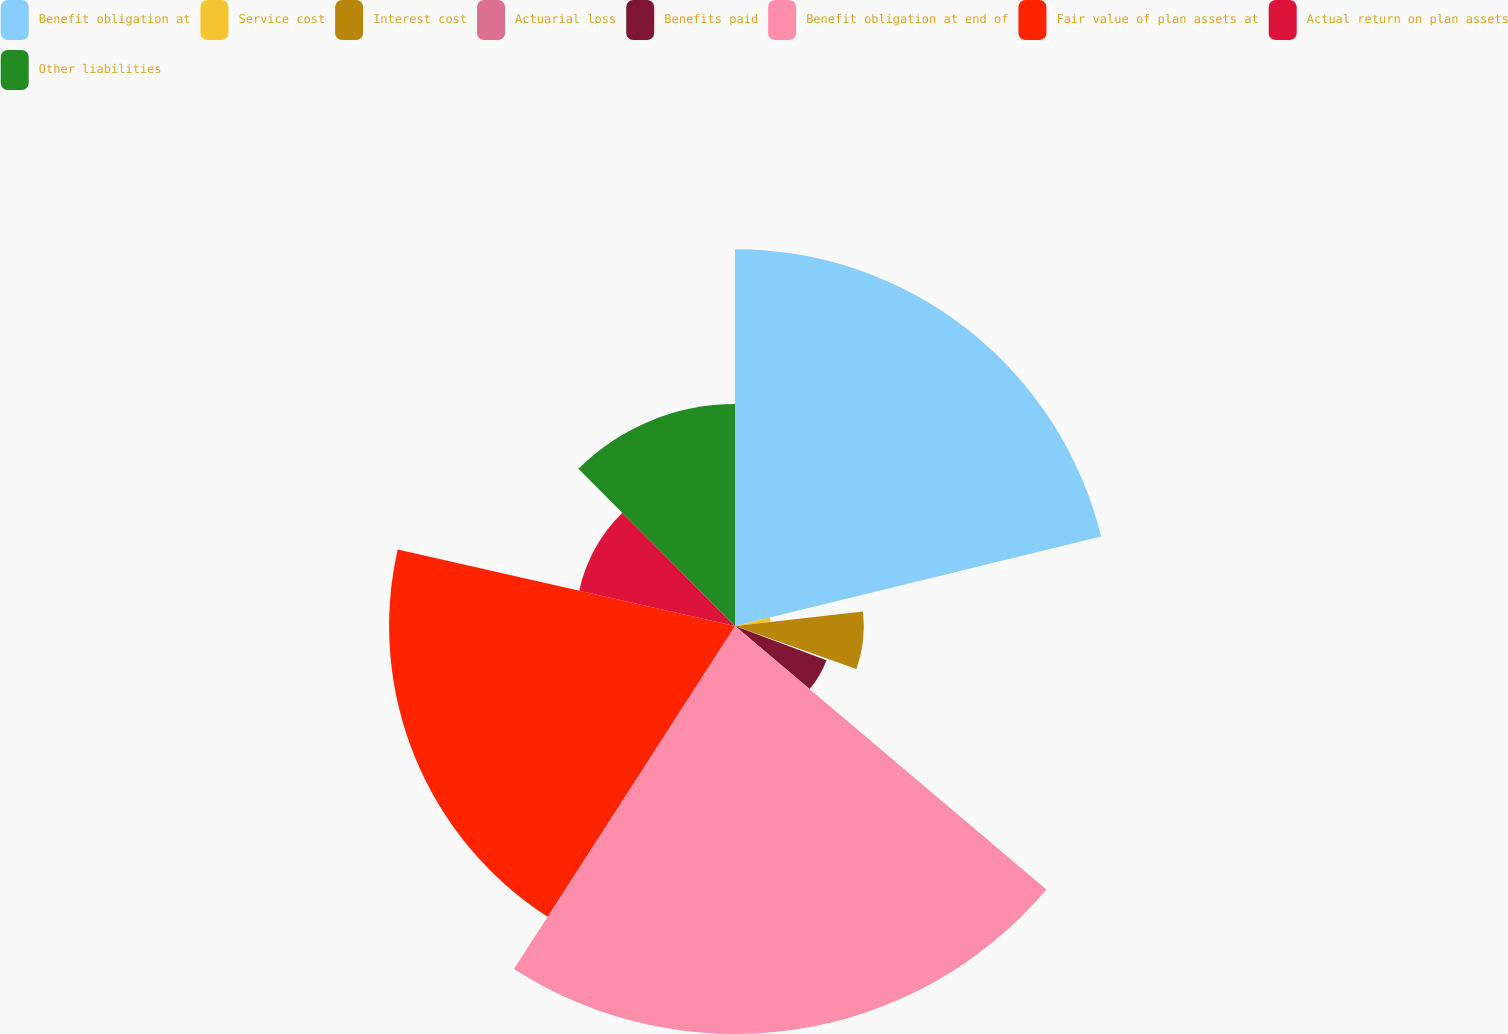<chart> <loc_0><loc_0><loc_500><loc_500><pie_chart><fcel>Benefit obligation at<fcel>Service cost<fcel>Interest cost<fcel>Actuarial loss<fcel>Benefits paid<fcel>Benefit obligation at end of<fcel>Fair value of plan assets at<fcel>Actual return on plan assets<fcel>Other liabilities<nl><fcel>21.18%<fcel>2.01%<fcel>7.24%<fcel>0.26%<fcel>5.49%<fcel>22.93%<fcel>19.44%<fcel>8.98%<fcel>12.47%<nl></chart> 